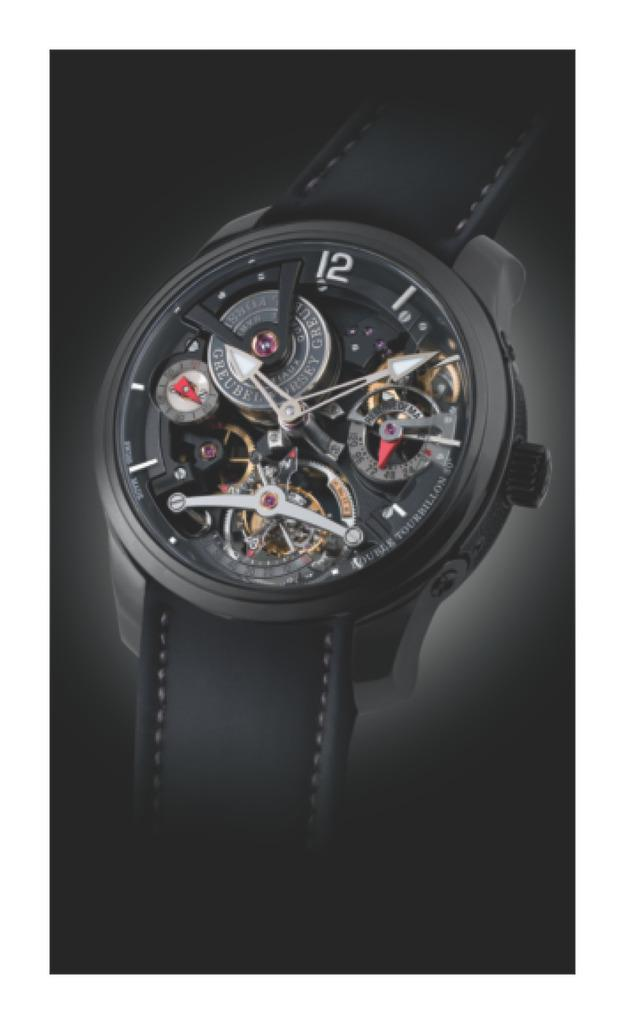<image>
Offer a succinct explanation of the picture presented. Nice black watch with only the number 12 on it. 